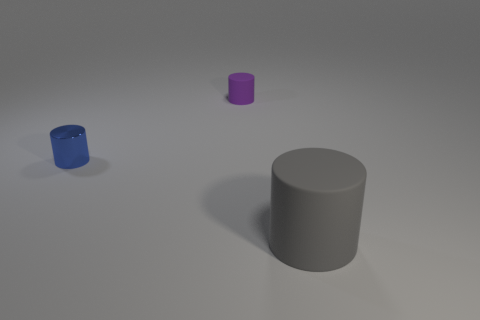Are there any other things that have the same size as the gray matte thing?
Offer a terse response. No. Is there any other thing that is made of the same material as the blue cylinder?
Provide a short and direct response. No. There is a thing that is made of the same material as the large cylinder; what size is it?
Ensure brevity in your answer.  Small. What is the material of the thing on the right side of the object that is behind the small cylinder that is in front of the purple object?
Provide a succinct answer. Rubber. Is the number of purple things less than the number of large brown things?
Give a very brief answer. No. Does the big object have the same material as the purple cylinder?
Keep it short and to the point. Yes. What number of rubber things are on the right side of the matte object on the left side of the gray matte cylinder?
Keep it short and to the point. 1. What color is the thing that is the same size as the blue cylinder?
Your answer should be compact. Purple. There is a cylinder that is to the right of the tiny rubber thing; what material is it?
Your response must be concise. Rubber. What is the cylinder that is both behind the gray matte thing and in front of the purple cylinder made of?
Give a very brief answer. Metal. 